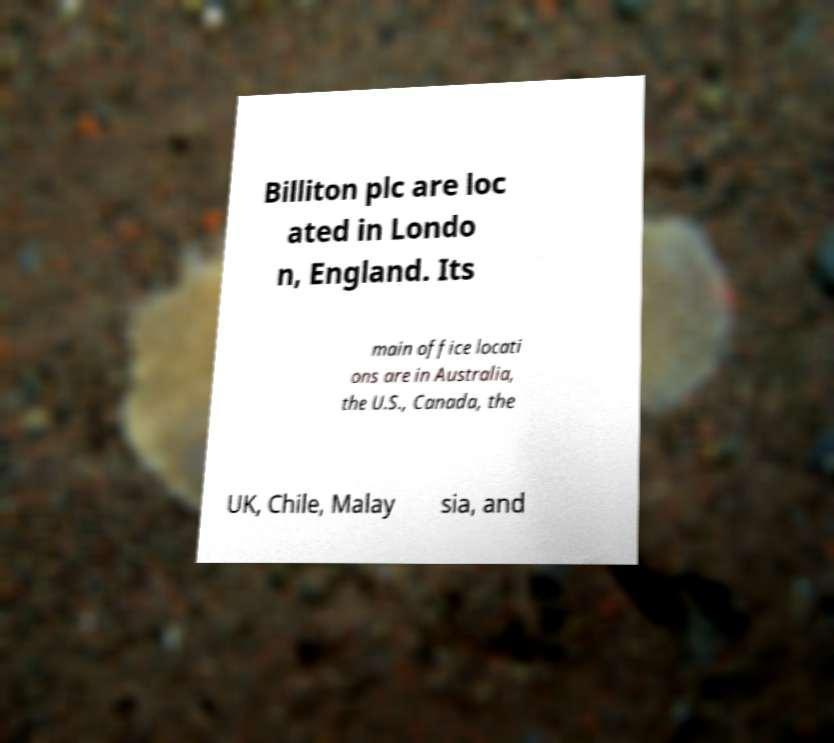There's text embedded in this image that I need extracted. Can you transcribe it verbatim? Billiton plc are loc ated in Londo n, England. Its main office locati ons are in Australia, the U.S., Canada, the UK, Chile, Malay sia, and 